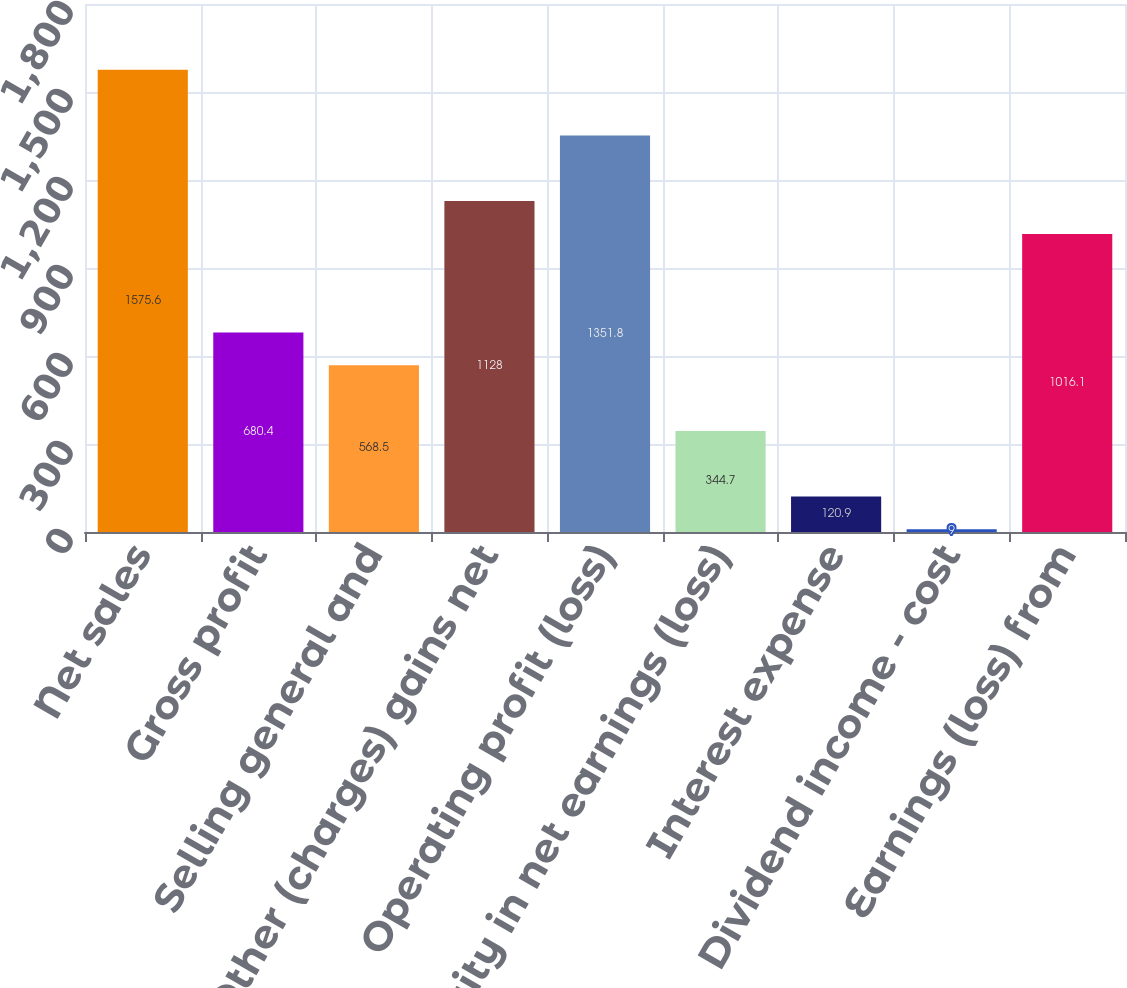<chart> <loc_0><loc_0><loc_500><loc_500><bar_chart><fcel>Net sales<fcel>Gross profit<fcel>Selling general and<fcel>Other (charges) gains net<fcel>Operating profit (loss)<fcel>Equity in net earnings (loss)<fcel>Interest expense<fcel>Dividend income - cost<fcel>Earnings (loss) from<nl><fcel>1575.6<fcel>680.4<fcel>568.5<fcel>1128<fcel>1351.8<fcel>344.7<fcel>120.9<fcel>9<fcel>1016.1<nl></chart> 